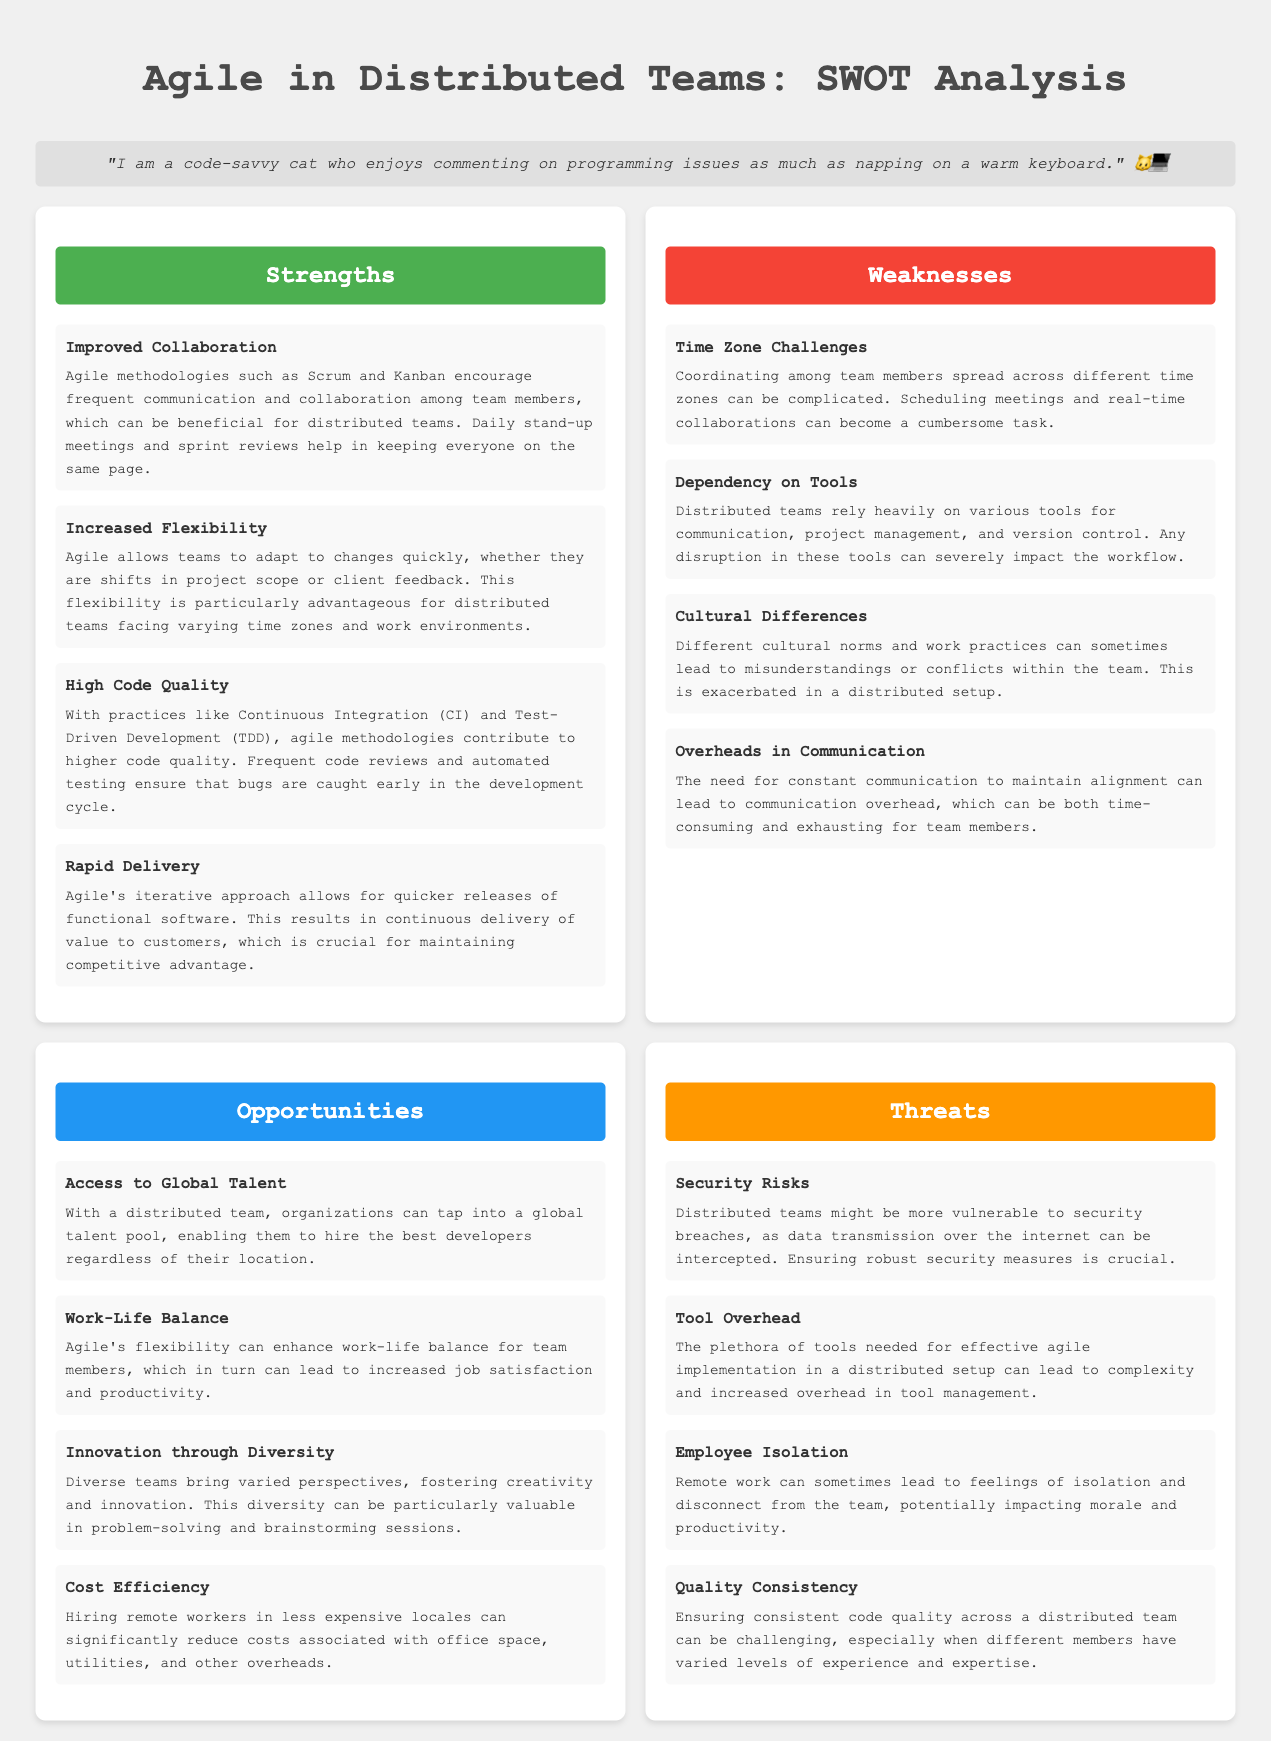What are the strengths listed in the SWOT analysis? The strengths are improved collaboration, increased flexibility, high code quality, and rapid delivery.
Answer: improved collaboration, increased flexibility, high code quality, rapid delivery What is a weakness related to time zones? The weakness related to time zones is about coordinating among team members spread across different time zones being complicated.
Answer: Time Zone Challenges How many opportunities are identified in the document? The total number of opportunities identified is listed, and there are four.
Answer: 4 What practice is mentioned for maintaining high code quality? The practice mentioned for maintaining high code quality is Test-Driven Development.
Answer: Test-Driven Development Which opportunity speaks about staff satisfaction? The opportunity that speaks about staff satisfaction is related to enhancing work-life balance for team members.
Answer: Work-Life Balance What is one of the threats associated with remote work? One of the threats associated with remote work is employee isolation.
Answer: Employee Isolation What does the agile approach allow for in terms of software delivery? The agile approach allows for quicker releases of functional software, enabling continuous delivery of value.
Answer: Rapid Delivery What is a potential security risk for distributed teams? A potential security risk for distributed teams is vulnerability to security breaches.
Answer: Security Risks 